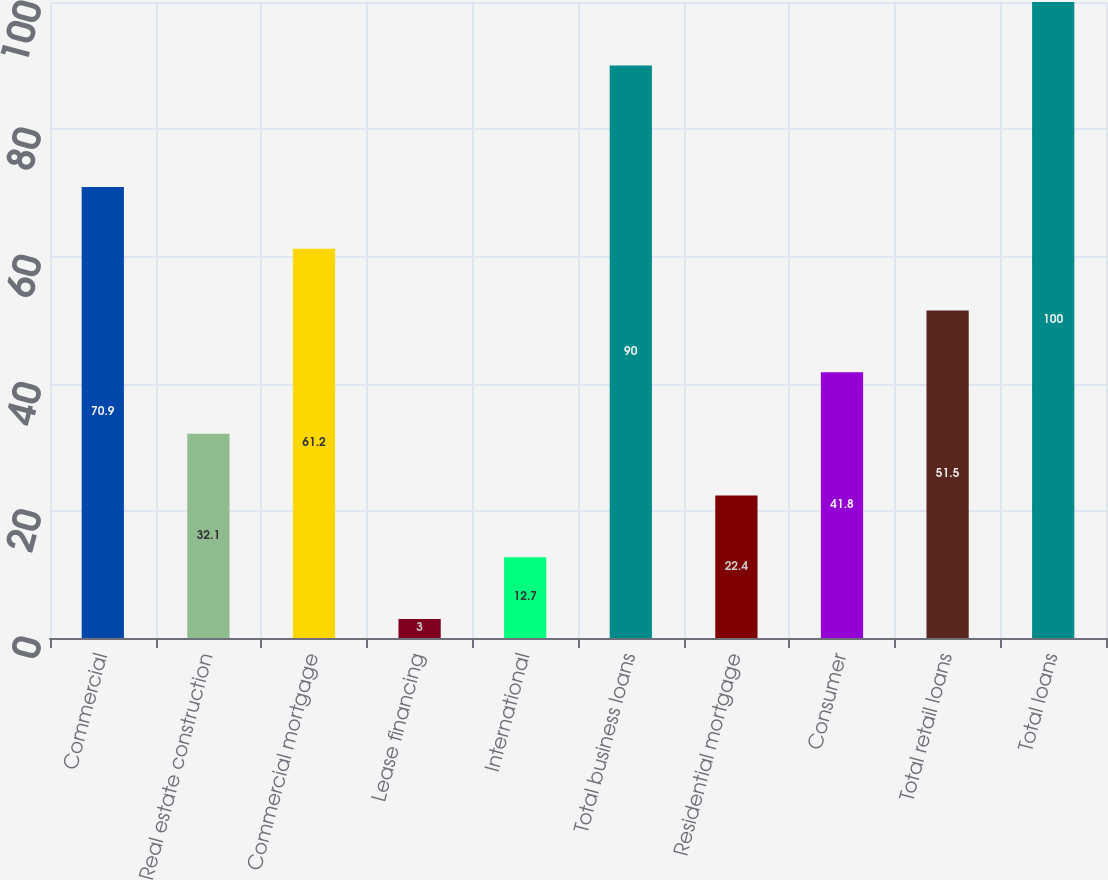Convert chart. <chart><loc_0><loc_0><loc_500><loc_500><bar_chart><fcel>Commercial<fcel>Real estate construction<fcel>Commercial mortgage<fcel>Lease financing<fcel>International<fcel>Total business loans<fcel>Residential mortgage<fcel>Consumer<fcel>Total retail loans<fcel>Total loans<nl><fcel>70.9<fcel>32.1<fcel>61.2<fcel>3<fcel>12.7<fcel>90<fcel>22.4<fcel>41.8<fcel>51.5<fcel>100<nl></chart> 